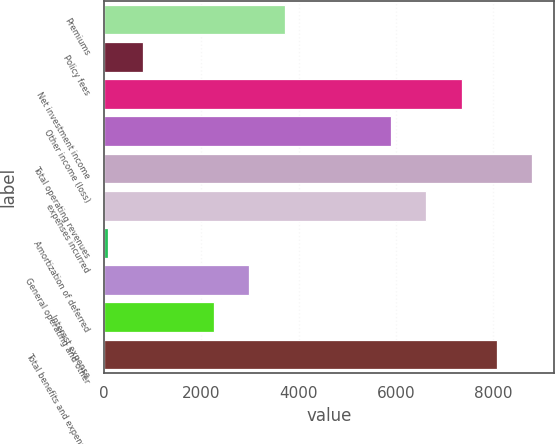Convert chart. <chart><loc_0><loc_0><loc_500><loc_500><bar_chart><fcel>Premiums<fcel>Policy fees<fcel>Net investment income<fcel>Other income (loss)<fcel>Total operating revenues<fcel>expenses incurred<fcel>Amortization of deferred<fcel>General operating and other<fcel>Interest expense<fcel>Total benefits and expenses<nl><fcel>3717<fcel>808.2<fcel>7353<fcel>5898.6<fcel>8807.4<fcel>6625.8<fcel>81<fcel>2989.8<fcel>2262.6<fcel>8080.2<nl></chart> 